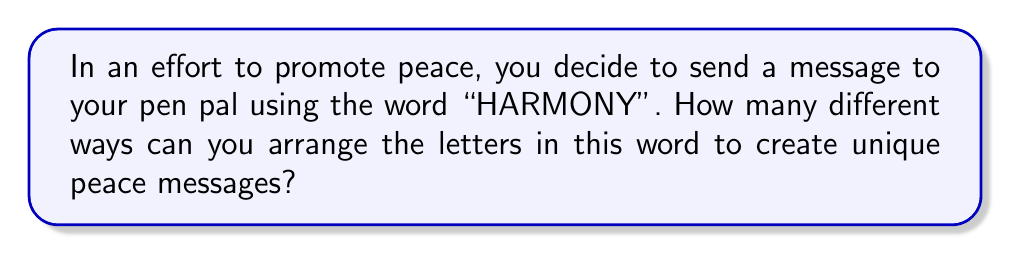Help me with this question. Let's approach this step-by-step:

1) First, we need to count the total number of letters in "HARMONY":
   There are 7 letters in total.

2) Next, we need to identify if there are any repeated letters:
   H: 1, A: 1, R: 1, M: 1, O: 1, N: 1, Y: 1
   There are no repeated letters.

3) Since there are no repeated letters, this is a straightforward permutation problem. We can use the formula:

   $$P = n!$$

   Where $n$ is the number of distinct objects (in this case, letters).

4) Plugging in our value:

   $$P = 7!$$

5) Let's calculate this:
   $$7! = 7 \times 6 \times 5 \times 4 \times 3 \times 2 \times 1 = 5040$$

Therefore, there are 5040 different ways to arrange the letters in "HARMONY" to create unique peace messages.
Answer: 5040 